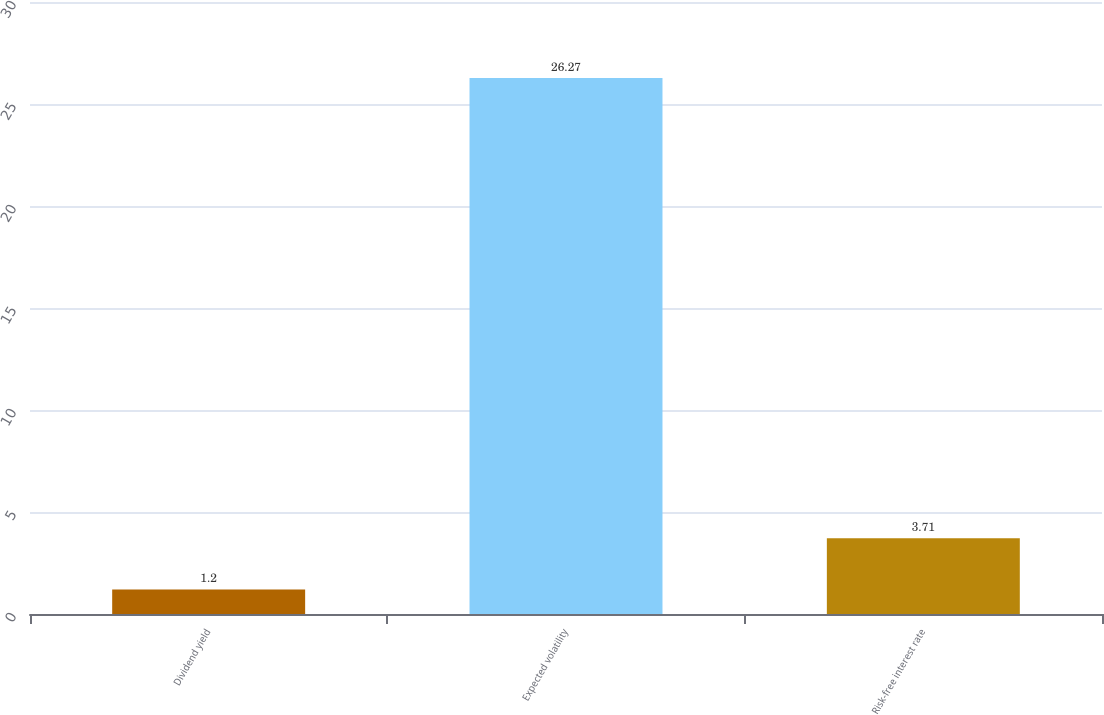<chart> <loc_0><loc_0><loc_500><loc_500><bar_chart><fcel>Dividend yield<fcel>Expected volatility<fcel>Risk-free interest rate<nl><fcel>1.2<fcel>26.27<fcel>3.71<nl></chart> 